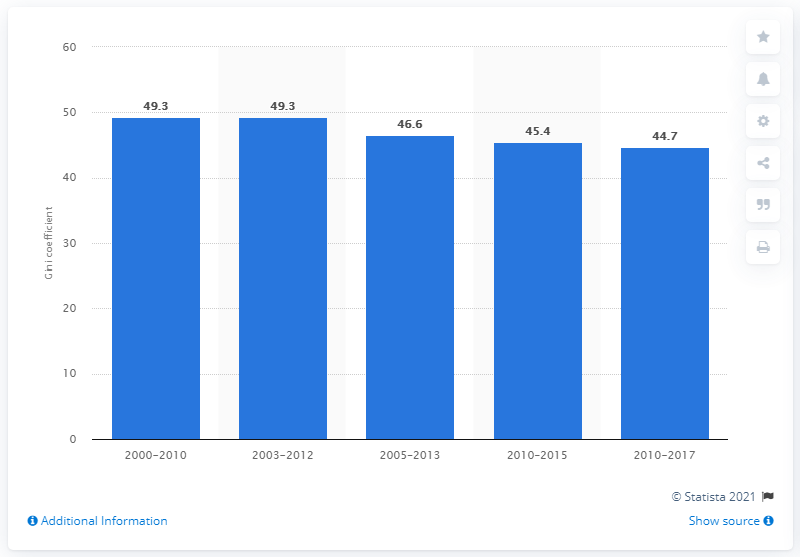Mention a couple of crucial points in this snapshot. According to data from 2017, Ecuador's Gini coefficient was 44.7, indicating a moderate level of income inequality in the country. 